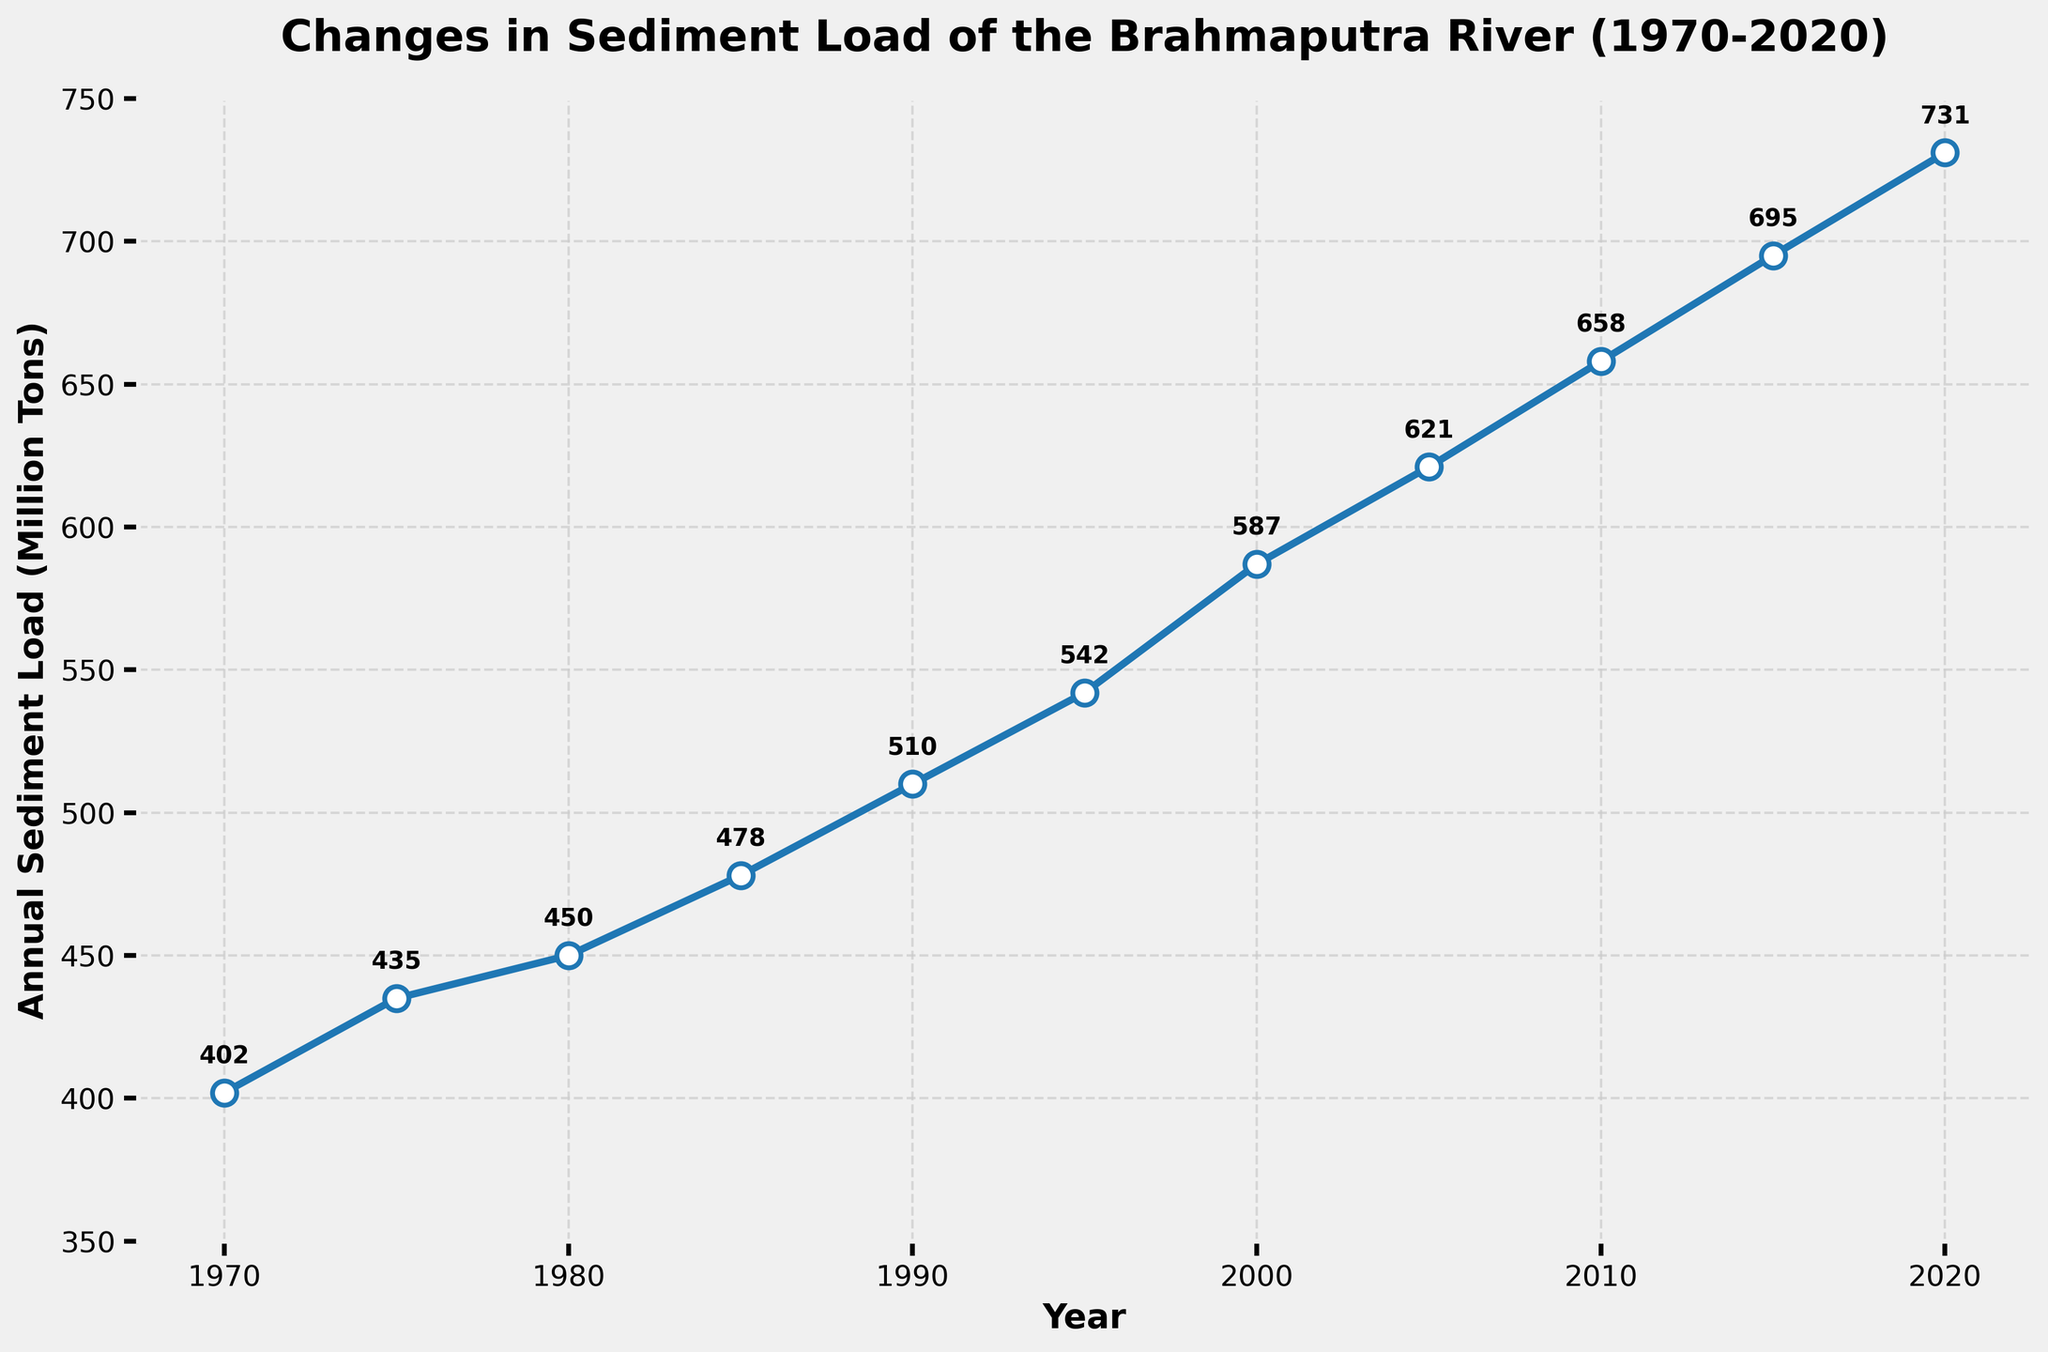What is the sediment load in the year 2000? The sediment load for the year 2000 can be directly read off the plot at the point where it corresponds to the x-axis value of 2000.
Answer: 587 How much did the sediment load increase between 1970 and 2020? Look at the sediment load values for 1970 (402 million tons) and for 2020 (731 million tons). Subtract the 1970 value from the 2020 value to find the increase: 731 - 402 = 329 million tons.
Answer: 329 million tons Between which two consecutive years did the sediment load show the greatest increase? Calculate the increase for each consecutive set of years: 
1970-1975: 435-402 = 33, 
1975-1980: 450-435 = 15, 
1980-1985: 478-450 = 28, 
1985-1990: 510-478 = 32, 
1990-1995: 542-510 = 32, 
1995-2000: 587-542 = 45, 
2000-2005: 621-587 = 34, 
2005-2010: 658-621 = 37, 
2010-2015: 695-658 = 37, 
2015-2020: 731-695 = 36. 
The greatest increase is between 1995-2000.
Answer: 1995-2000 What is the average annual sediment load for the period 1970 to 2020? Sum the sediment load values for all years and divide by the number of data points (11): (402+435+450+478+510+542+587+621+658+695+731) / 11 = 6,109 / 11 = 555.36 million tons.
Answer: 555.36 million tons In which year did the sediment load first exceed 500 million tons? Check each year in the data until the sediment load exceeds 500 million tons. The sediment load exceeded 500 million tons for the first time in 1990 (510 million tons).
Answer: 1990 What is the slope of the line between 1970 and 1980? The slope is calculated as the change in sediment load divided by the change in years. For 1970 (402 million tons) to 1980 (450 million tons): Slope = (450-402) / (1980-1970) = 48 / 10 = 4.8 million tons per year.
Answer: 4.8 million tons per year Compare the sediment loads in 1985 and 2005. Which year had a higher sediment load, and by how much? From the plot, reading values for 1985 (478 million tons) and 2005 (621 million tons). Subtract the value for 1985 from the value for 2005: 621 - 478 = 143 million tons. The year 2005 had a higher sediment load by 143 million tons.
Answer: 2005 by 143 million tons What is the overall trend in sediment load from 1970 to 2020? Observe the plot shape from 1970 to 2020. The overall trend shows an upward increasing pattern.
Answer: Increasing 